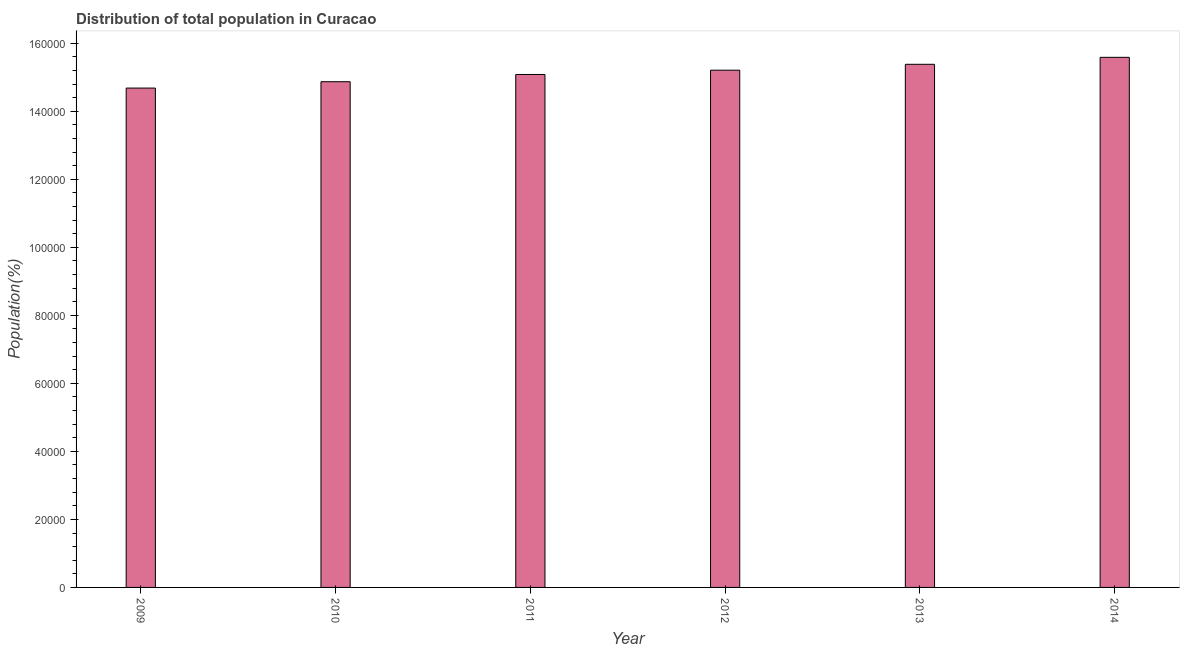What is the title of the graph?
Make the answer very short. Distribution of total population in Curacao . What is the label or title of the X-axis?
Ensure brevity in your answer.  Year. What is the label or title of the Y-axis?
Offer a very short reply. Population(%). What is the population in 2010?
Offer a terse response. 1.49e+05. Across all years, what is the maximum population?
Keep it short and to the point. 1.56e+05. Across all years, what is the minimum population?
Offer a terse response. 1.47e+05. In which year was the population minimum?
Ensure brevity in your answer.  2009. What is the sum of the population?
Provide a succinct answer. 9.08e+05. What is the difference between the population in 2010 and 2012?
Your answer should be compact. -3385. What is the average population per year?
Give a very brief answer. 1.51e+05. What is the median population?
Offer a very short reply. 1.51e+05. In how many years, is the population greater than 112000 %?
Your answer should be compact. 6. Is the population in 2010 less than that in 2014?
Ensure brevity in your answer.  Yes. Is the difference between the population in 2013 and 2014 greater than the difference between any two years?
Offer a very short reply. No. What is the difference between the highest and the second highest population?
Make the answer very short. 2051. What is the difference between the highest and the lowest population?
Provide a succinct answer. 9039. What is the difference between two consecutive major ticks on the Y-axis?
Ensure brevity in your answer.  2.00e+04. Are the values on the major ticks of Y-axis written in scientific E-notation?
Give a very brief answer. No. What is the Population(%) of 2009?
Provide a short and direct response. 1.47e+05. What is the Population(%) in 2010?
Your response must be concise. 1.49e+05. What is the Population(%) of 2011?
Your answer should be compact. 1.51e+05. What is the Population(%) of 2012?
Make the answer very short. 1.52e+05. What is the Population(%) in 2013?
Provide a succinct answer. 1.54e+05. What is the Population(%) in 2014?
Offer a terse response. 1.56e+05. What is the difference between the Population(%) in 2009 and 2010?
Your answer should be compact. -1870. What is the difference between the Population(%) in 2009 and 2011?
Give a very brief answer. -3998. What is the difference between the Population(%) in 2009 and 2012?
Provide a short and direct response. -5255. What is the difference between the Population(%) in 2009 and 2013?
Make the answer very short. -6988. What is the difference between the Population(%) in 2009 and 2014?
Give a very brief answer. -9039. What is the difference between the Population(%) in 2010 and 2011?
Give a very brief answer. -2128. What is the difference between the Population(%) in 2010 and 2012?
Offer a very short reply. -3385. What is the difference between the Population(%) in 2010 and 2013?
Make the answer very short. -5118. What is the difference between the Population(%) in 2010 and 2014?
Ensure brevity in your answer.  -7169. What is the difference between the Population(%) in 2011 and 2012?
Give a very brief answer. -1257. What is the difference between the Population(%) in 2011 and 2013?
Your answer should be very brief. -2990. What is the difference between the Population(%) in 2011 and 2014?
Your answer should be compact. -5041. What is the difference between the Population(%) in 2012 and 2013?
Your answer should be compact. -1733. What is the difference between the Population(%) in 2012 and 2014?
Offer a very short reply. -3784. What is the difference between the Population(%) in 2013 and 2014?
Your response must be concise. -2051. What is the ratio of the Population(%) in 2009 to that in 2010?
Make the answer very short. 0.99. What is the ratio of the Population(%) in 2009 to that in 2011?
Offer a terse response. 0.97. What is the ratio of the Population(%) in 2009 to that in 2013?
Provide a succinct answer. 0.95. What is the ratio of the Population(%) in 2009 to that in 2014?
Your answer should be very brief. 0.94. What is the ratio of the Population(%) in 2010 to that in 2011?
Your response must be concise. 0.99. What is the ratio of the Population(%) in 2010 to that in 2012?
Offer a very short reply. 0.98. What is the ratio of the Population(%) in 2010 to that in 2013?
Ensure brevity in your answer.  0.97. What is the ratio of the Population(%) in 2010 to that in 2014?
Give a very brief answer. 0.95. What is the ratio of the Population(%) in 2011 to that in 2014?
Make the answer very short. 0.97. What is the ratio of the Population(%) in 2012 to that in 2014?
Provide a succinct answer. 0.98. 